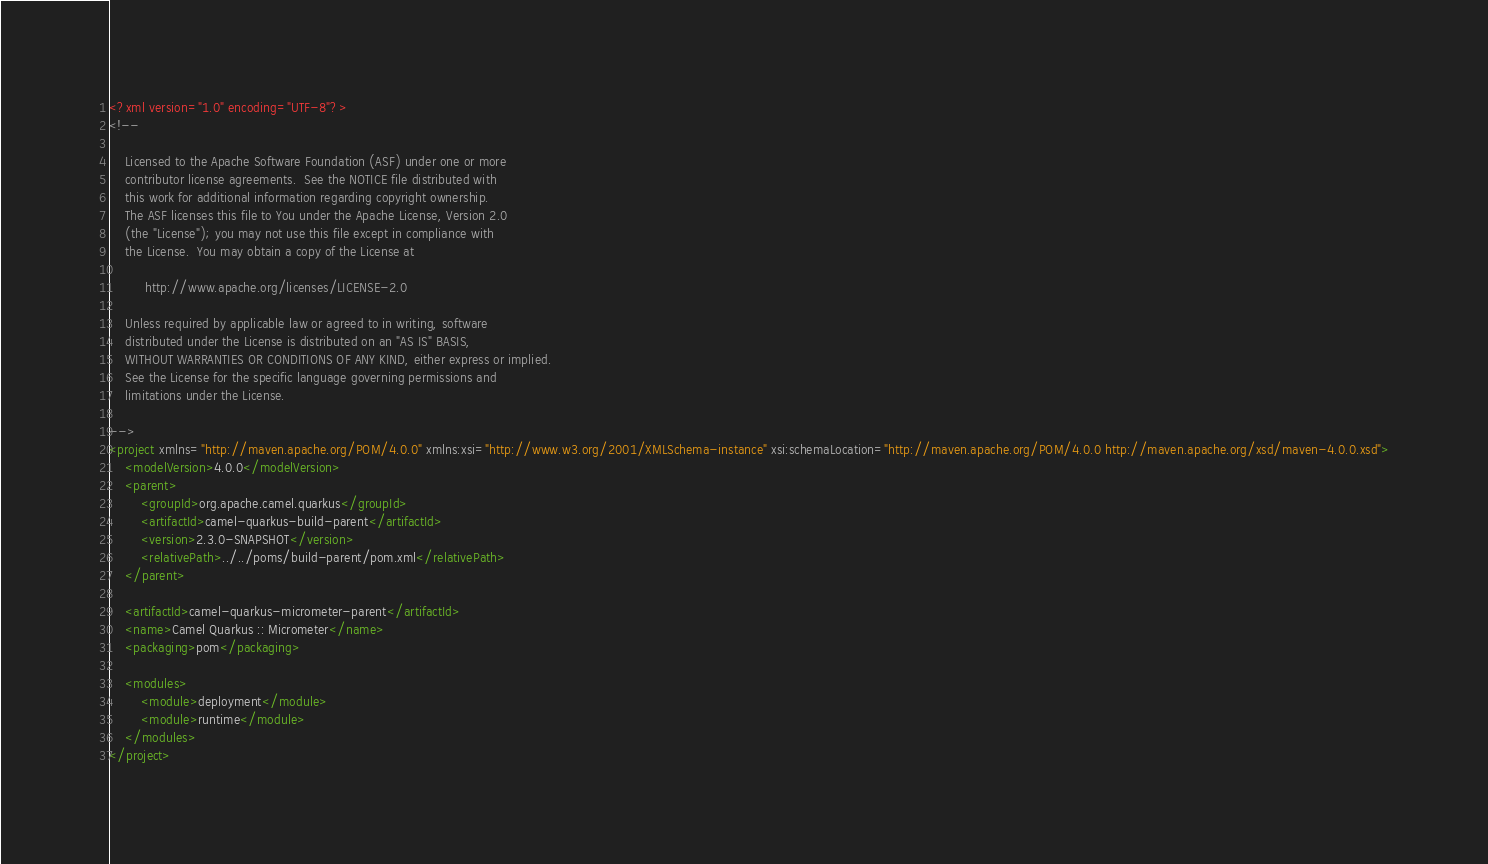Convert code to text. <code><loc_0><loc_0><loc_500><loc_500><_XML_><?xml version="1.0" encoding="UTF-8"?>
<!--

    Licensed to the Apache Software Foundation (ASF) under one or more
    contributor license agreements.  See the NOTICE file distributed with
    this work for additional information regarding copyright ownership.
    The ASF licenses this file to You under the Apache License, Version 2.0
    (the "License"); you may not use this file except in compliance with
    the License.  You may obtain a copy of the License at

         http://www.apache.org/licenses/LICENSE-2.0

    Unless required by applicable law or agreed to in writing, software
    distributed under the License is distributed on an "AS IS" BASIS,
    WITHOUT WARRANTIES OR CONDITIONS OF ANY KIND, either express or implied.
    See the License for the specific language governing permissions and
    limitations under the License.

-->
<project xmlns="http://maven.apache.org/POM/4.0.0" xmlns:xsi="http://www.w3.org/2001/XMLSchema-instance" xsi:schemaLocation="http://maven.apache.org/POM/4.0.0 http://maven.apache.org/xsd/maven-4.0.0.xsd">
    <modelVersion>4.0.0</modelVersion>
    <parent>
        <groupId>org.apache.camel.quarkus</groupId>
        <artifactId>camel-quarkus-build-parent</artifactId>
        <version>2.3.0-SNAPSHOT</version>
        <relativePath>../../poms/build-parent/pom.xml</relativePath>
    </parent>

    <artifactId>camel-quarkus-micrometer-parent</artifactId>
    <name>Camel Quarkus :: Micrometer</name>
    <packaging>pom</packaging>

    <modules>
        <module>deployment</module>
        <module>runtime</module>
    </modules>
</project>
</code> 